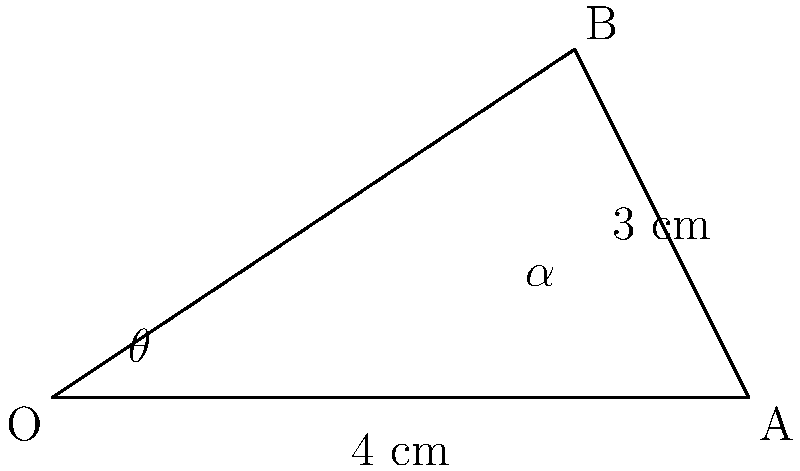In a martial arts competition, you're analyzing the angle of impact for a punch. The fist travels 4 cm horizontally and 3 cm vertically. What is the angle $\alpha$ (in degrees) between the punch trajectory and the horizontal plane? To solve this problem, we'll use trigonometry:

1) The punch trajectory forms a right triangle with the horizontal and vertical components.

2) We can use the arctangent function to find the angle $\alpha$:

   $\alpha = \arctan(\frac{\text{opposite}}{\text{adjacent}})$

3) The opposite side (vertical component) is 3 cm, and the adjacent side (horizontal component) is 4 cm.

4) Substituting these values:

   $\alpha = \arctan(\frac{3}{4})$

5) Using a calculator or trigonometric tables:

   $\alpha \approx 36.87°$

6) Rounding to the nearest degree:

   $\alpha \approx 37°$
Answer: $37°$ 